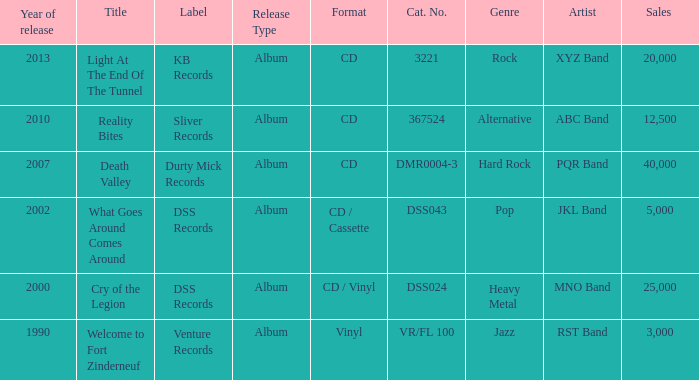What is the total year of release of the title what goes around comes around? 1.0. 